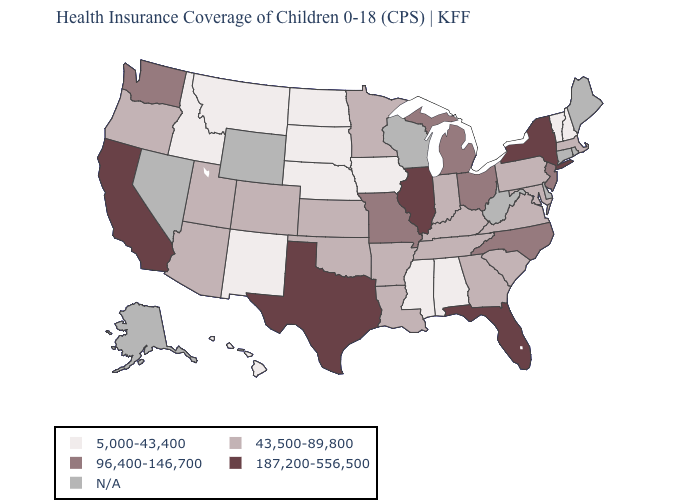What is the value of Mississippi?
Keep it brief. 5,000-43,400. Name the states that have a value in the range 5,000-43,400?
Concise answer only. Alabama, Hawaii, Idaho, Iowa, Mississippi, Montana, Nebraska, New Hampshire, New Mexico, North Dakota, South Dakota, Vermont. Which states have the highest value in the USA?
Quick response, please. California, Florida, Illinois, New York, Texas. Name the states that have a value in the range N/A?
Quick response, please. Alaska, Connecticut, Delaware, Maine, Nevada, Rhode Island, West Virginia, Wisconsin, Wyoming. What is the value of Montana?
Answer briefly. 5,000-43,400. What is the lowest value in the USA?
Be succinct. 5,000-43,400. Name the states that have a value in the range 43,500-89,800?
Write a very short answer. Arizona, Arkansas, Colorado, Georgia, Indiana, Kansas, Kentucky, Louisiana, Maryland, Massachusetts, Minnesota, Oklahoma, Oregon, Pennsylvania, South Carolina, Tennessee, Utah, Virginia. Name the states that have a value in the range 187,200-556,500?
Concise answer only. California, Florida, Illinois, New York, Texas. What is the highest value in the MidWest ?
Be succinct. 187,200-556,500. What is the highest value in states that border Missouri?
Short answer required. 187,200-556,500. Is the legend a continuous bar?
Be succinct. No. Name the states that have a value in the range 43,500-89,800?
Quick response, please. Arizona, Arkansas, Colorado, Georgia, Indiana, Kansas, Kentucky, Louisiana, Maryland, Massachusetts, Minnesota, Oklahoma, Oregon, Pennsylvania, South Carolina, Tennessee, Utah, Virginia. Name the states that have a value in the range 43,500-89,800?
Be succinct. Arizona, Arkansas, Colorado, Georgia, Indiana, Kansas, Kentucky, Louisiana, Maryland, Massachusetts, Minnesota, Oklahoma, Oregon, Pennsylvania, South Carolina, Tennessee, Utah, Virginia. 